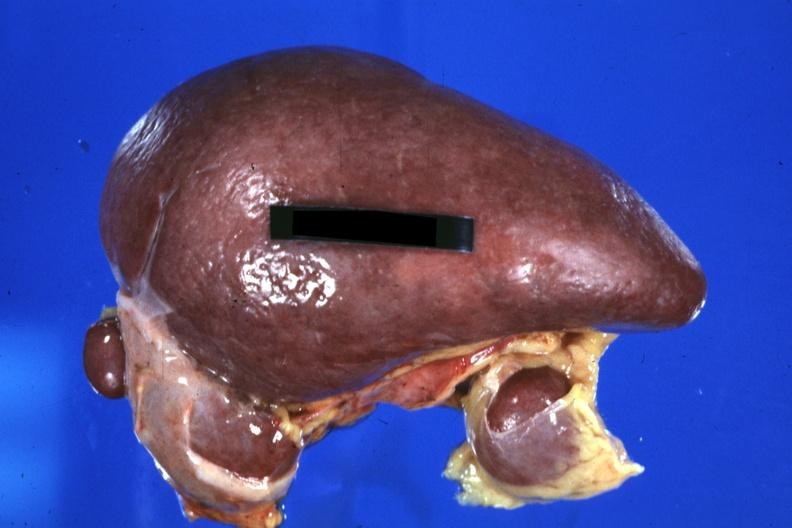what is spleen with three accessories 32yobf left?
Answer the question using a single word or phrase. Isomerism and complex congenital heart disease 